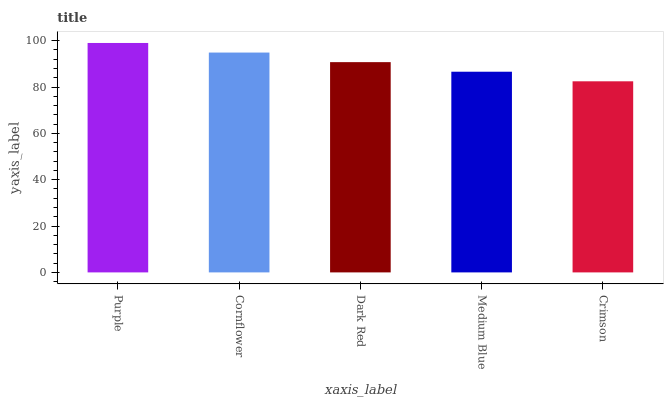Is Cornflower the minimum?
Answer yes or no. No. Is Cornflower the maximum?
Answer yes or no. No. Is Purple greater than Cornflower?
Answer yes or no. Yes. Is Cornflower less than Purple?
Answer yes or no. Yes. Is Cornflower greater than Purple?
Answer yes or no. No. Is Purple less than Cornflower?
Answer yes or no. No. Is Dark Red the high median?
Answer yes or no. Yes. Is Dark Red the low median?
Answer yes or no. Yes. Is Purple the high median?
Answer yes or no. No. Is Crimson the low median?
Answer yes or no. No. 